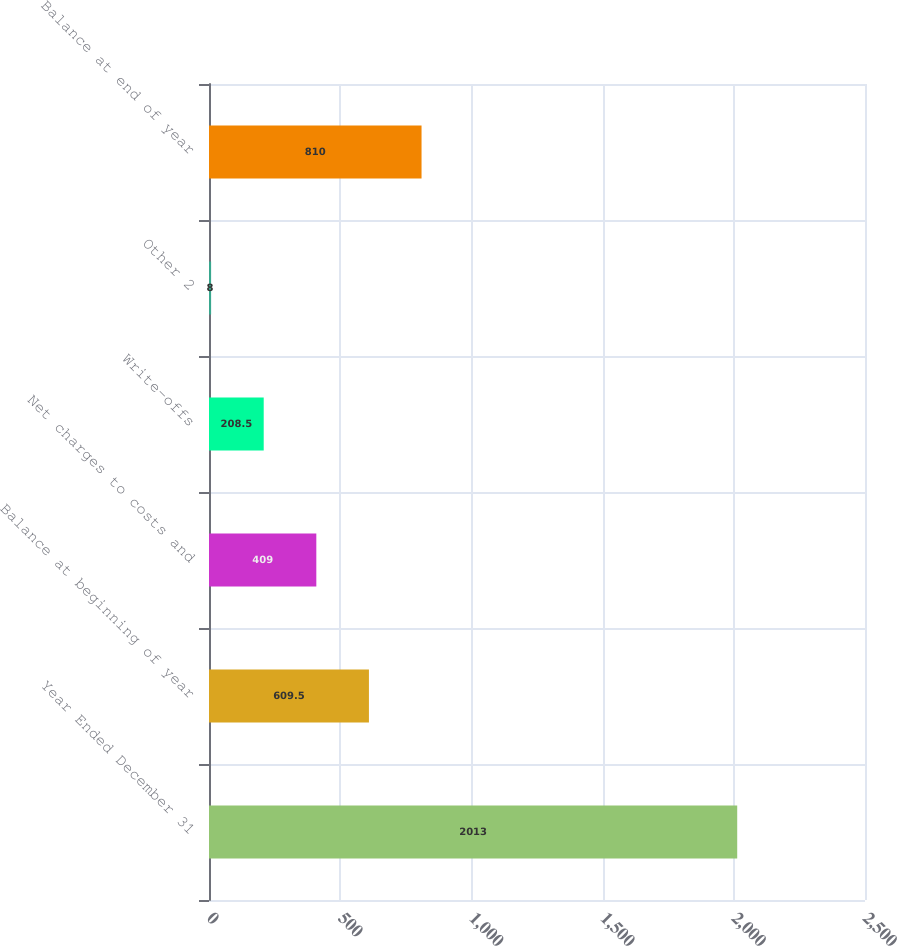<chart> <loc_0><loc_0><loc_500><loc_500><bar_chart><fcel>Year Ended December 31<fcel>Balance at beginning of year<fcel>Net charges to costs and<fcel>Write-offs<fcel>Other 2<fcel>Balance at end of year<nl><fcel>2013<fcel>609.5<fcel>409<fcel>208.5<fcel>8<fcel>810<nl></chart> 